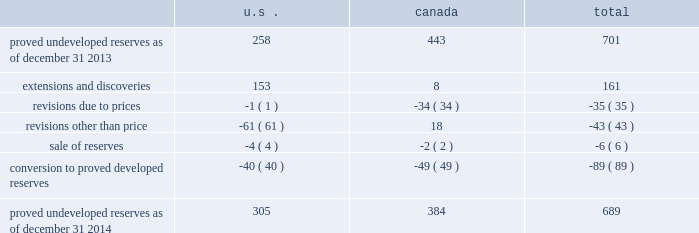Devon energy corporation and subsidiaries notes to consolidated financial statements 2013 ( continued ) proved undeveloped reserves the table presents the changes in devon 2019s total proved undeveloped reserves during 2014 ( in mmboe ) . .
At december 31 , 2014 , devon had 689 mmboe of proved undeveloped reserves .
This represents a 2 percent decrease as compared to 2013 and represents 25 percent of total proved reserves .
Drilling and development activities increased devon 2019s proved undeveloped reserves 161 mmboe and resulted in the conversion of 89 mmboe , or 13 percent , of the 2013 proved undeveloped reserves to proved developed reserves .
Costs incurred related to the development and conversion of devon 2019s proved undeveloped reserves were approximately $ 1.0 billion for 2014 .
Additionally , revisions other than price decreased devon 2019s proved undeveloped reserves 43 mmboe primarily due to evaluations of certain u.s .
Onshore dry-gas areas , which devon does not expect to develop in the next five years .
The largest revisions , which were approximately 69 mmboe , relate to the dry-gas areas in the barnett shale in north texas .
A significant amount of devon 2019s proved undeveloped reserves at the end of 2014 related to its jackfish operations .
At december 31 , 2014 and 2013 , devon 2019s jackfish proved undeveloped reserves were 384 mmboe and 441 mmboe , respectively .
Development schedules for the jackfish reserves are primarily controlled by the need to keep the processing plants at their 35000 barrel daily facility capacity .
Processing plant capacity is controlled by factors such as total steam processing capacity and steam-oil ratios .
Furthermore , development of these projects involves the up-front construction of steam injection/distribution and bitumen processing facilities .
Due to the large up-front capital investments and large reserves required to provide economic returns , the project conditions meet the specific circumstances requiring a period greater than 5 years for conversion to developed reserves .
As a result , these reserves are classified as proved undeveloped for more than five years .
Currently , the development schedule for these reserves extends though the year 2031 .
Price revisions 2014 2013 reserves increased 9 mmboe primarily due to higher gas prices in the barnett shale and the anadarko basin , partially offset by higher bitumen prices , which result in lower after-royalty volumes , in canada .
2013 2013 reserves increased 94 mmboe primarily due to higher gas prices .
Of this increase , 43 mmboe related to the barnett shale and 19 mmboe related to the rocky mountain area .
2012 2013 reserves decreased 171 mmboe primarily due to lower gas prices .
Of this decrease , 100 mmboe related to the barnett shale and 25 mmboe related to the rocky mountain area. .
What percentage of total proved undeveloped resources as of dec 31 , 2014 does extensions and discoveries and proved undeveloped resources as of dec 31 , 2013 account for? 
Computations: (((701 + 161) / 689) * 100)
Answer: 125.10885. 